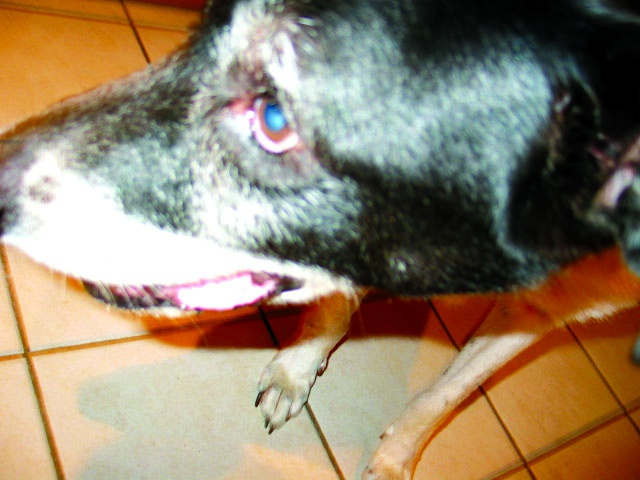Describe the objects in this image and their specific colors. I can see a dog in maroon, black, white, darkgray, and gray tones in this image. 